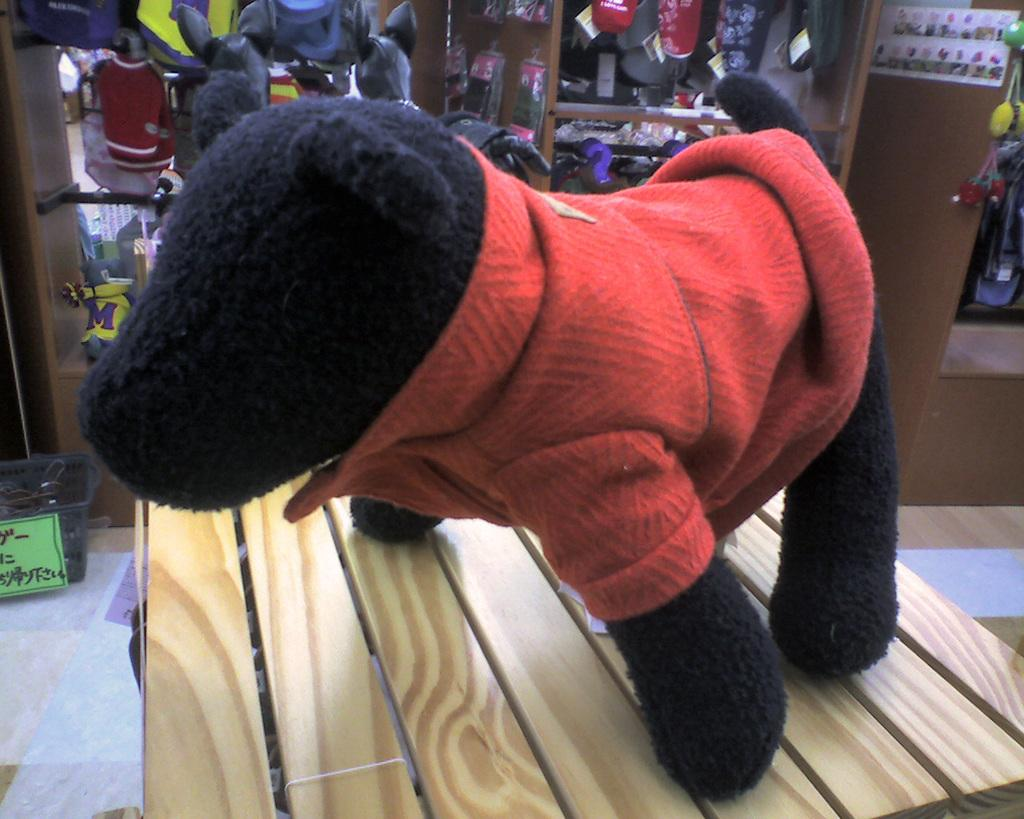What is the color of the toy in the image? The toy in the image has black and red colors. What is the toy placed on in the image? The toy is on a brown surface. Can you describe the background of the image? There are objects visible in the background of the image. What type of lipstick is being used on the toy in the image? There is no lipstick or any cosmetic product visible in the image. The toy is simply a black and red color toy placed on a brown surface. 